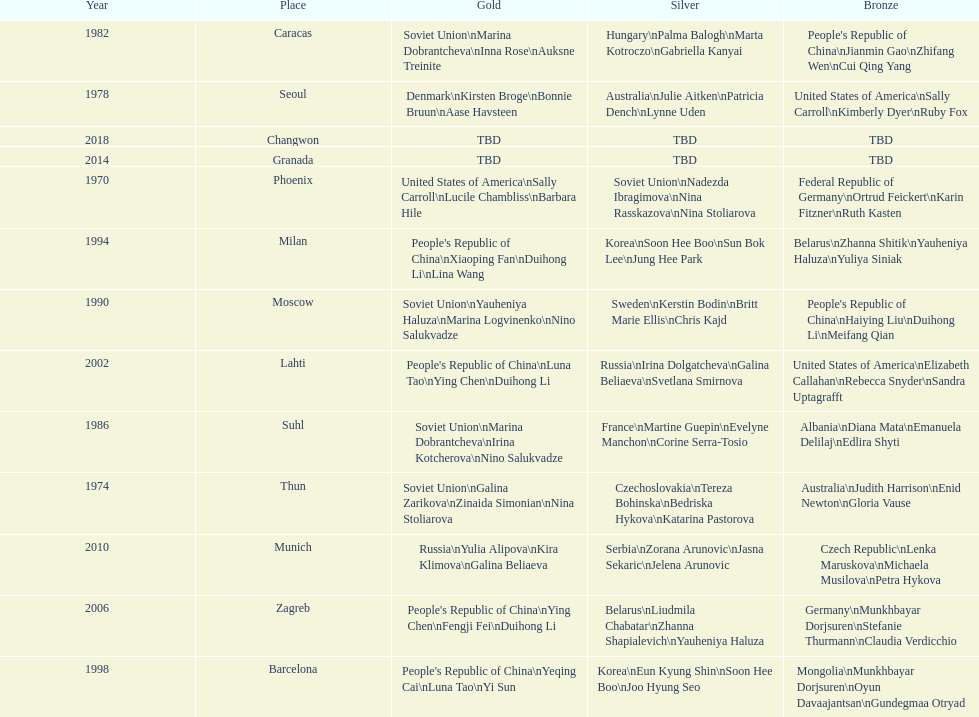What are the total number of times the soviet union is listed under the gold column? 4. 